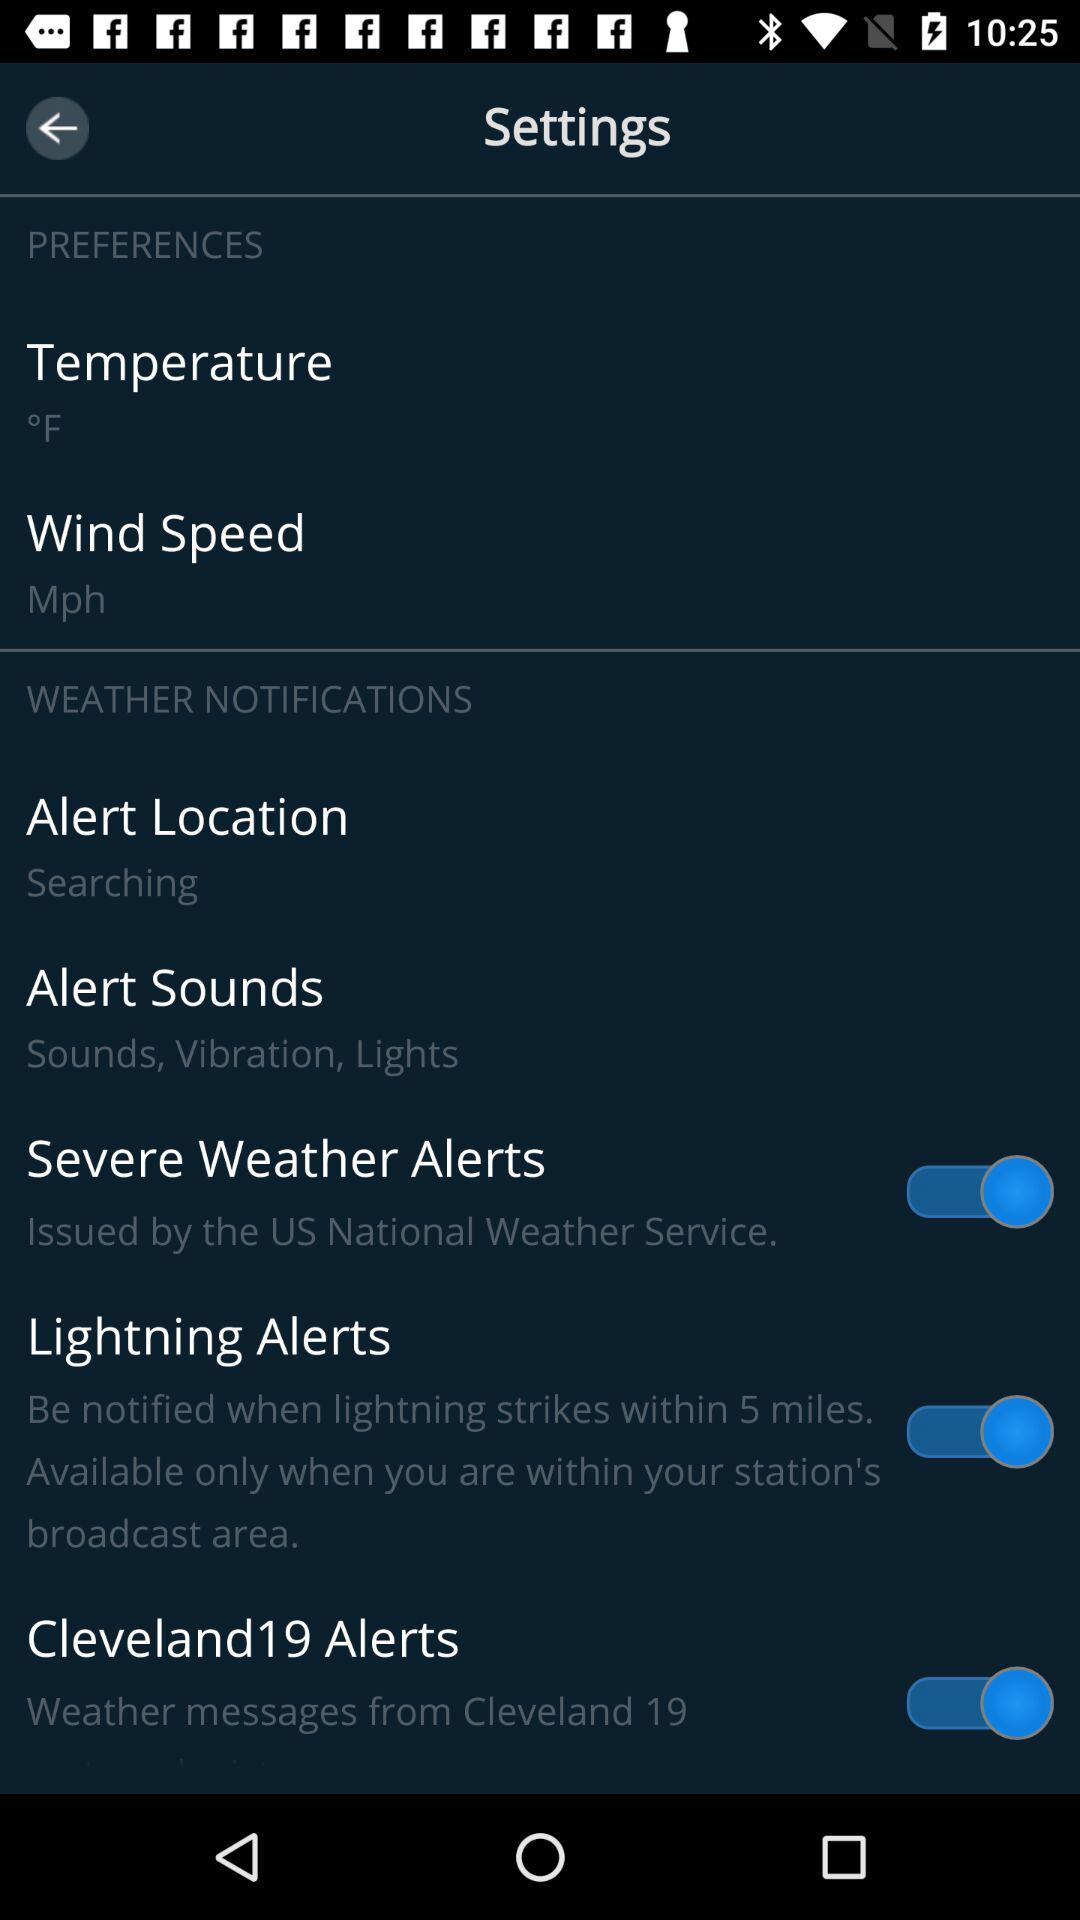How many alert options are there?
Answer the question using a single word or phrase. 4 